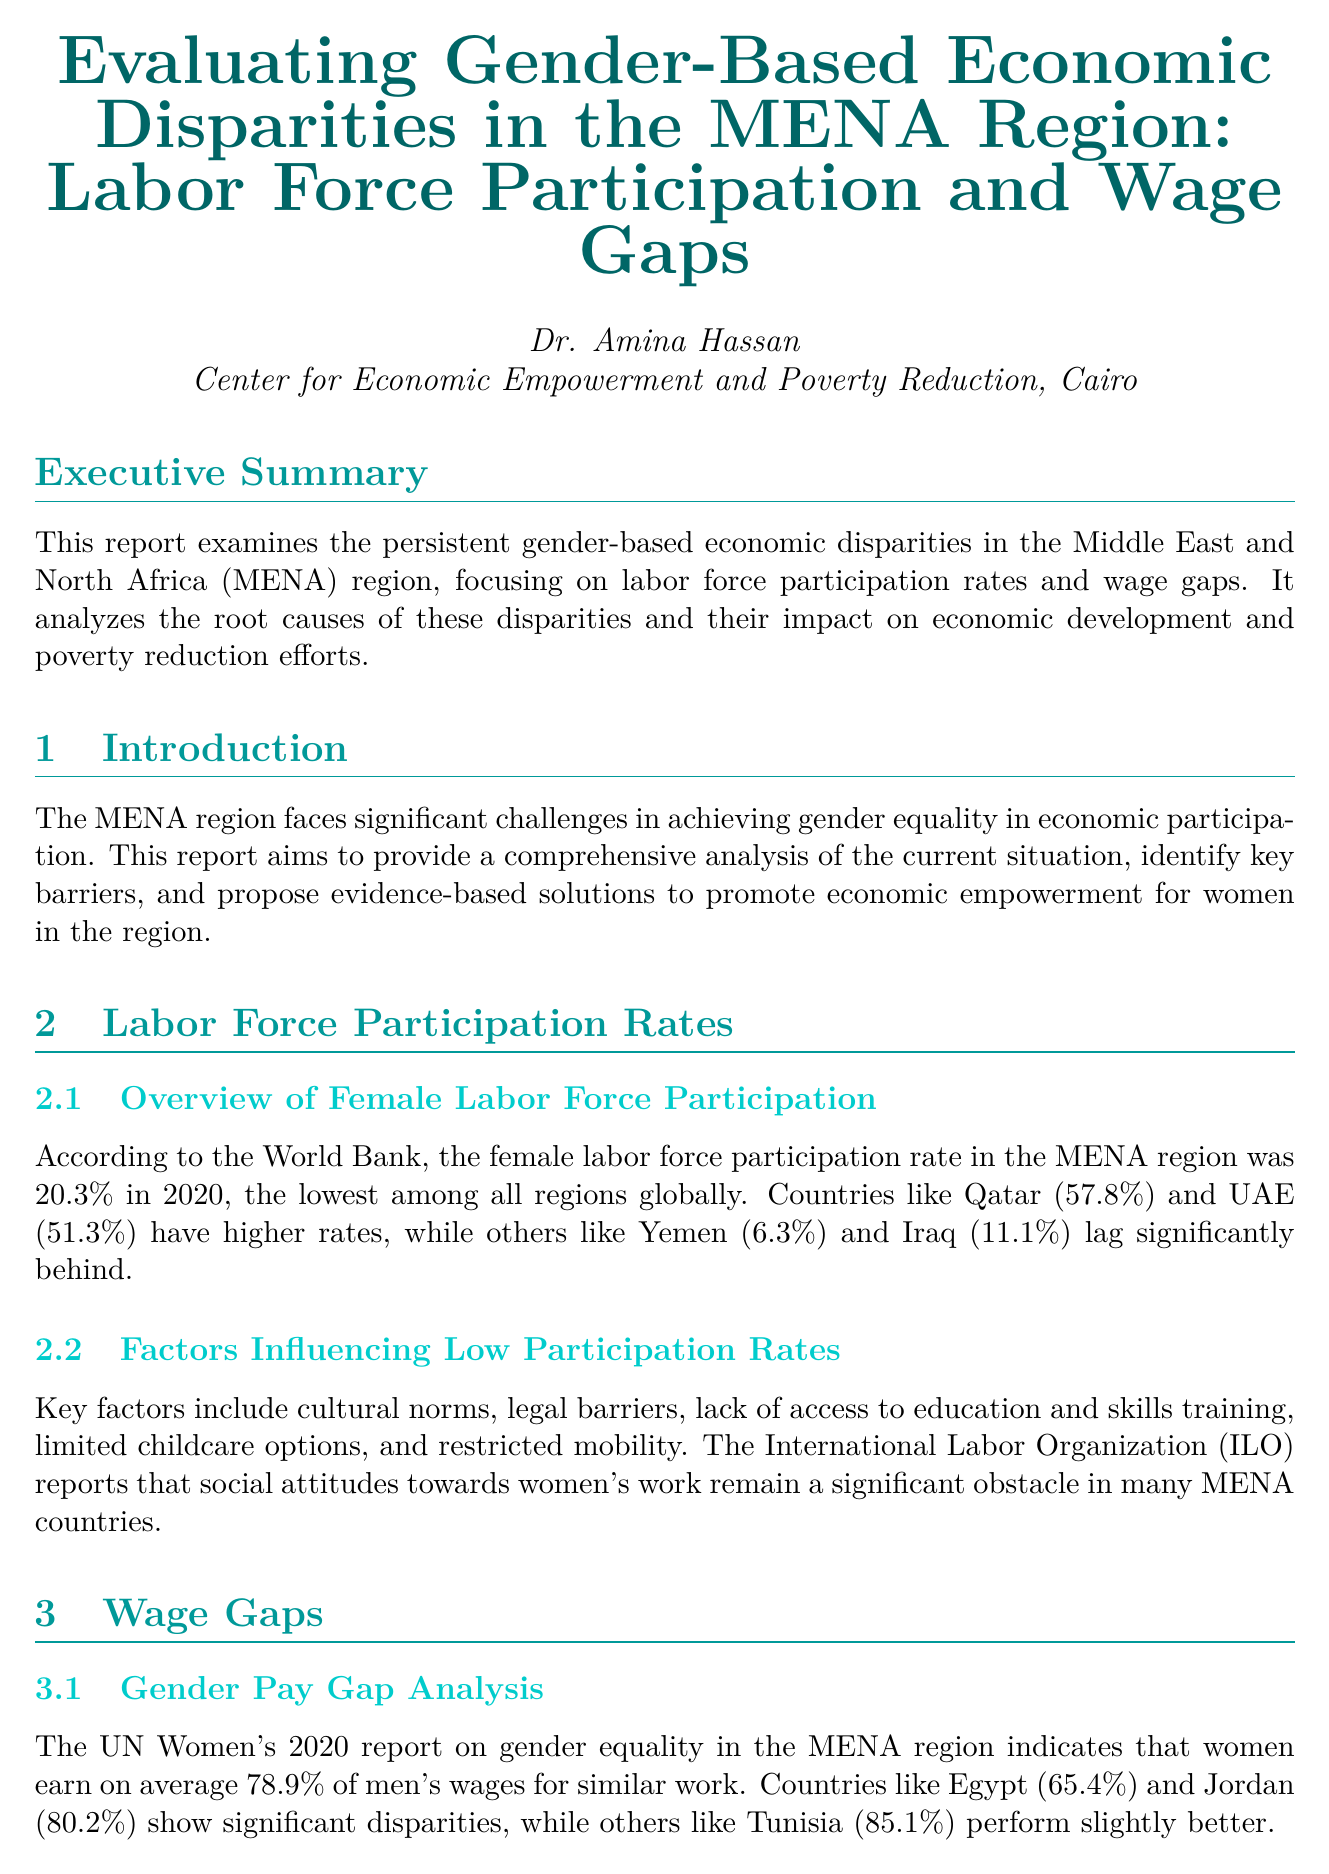What was the female labor force participation rate in the MENA region in 2020? The report states that the female labor force participation rate in the MENA region was 20.3% in 2020.
Answer: 20.3% Which country had the highest female labor force participation rate in the MENA region? According to the report, Qatar had the highest female labor force participation rate at 57.8%.
Answer: Qatar What percentage do women earn on average compared to men for similar work in the MENA region? The UN Women's 2020 report indicates that women earn on average 78.9% of men's wages for similar work.
Answer: 78.9% Which policy is recommended to support work-life balance? The report recommends implementing policies to support work-life balance, including parental leave and affordable childcare.
Answer: Parental leave and affordable childcare What economic benefit could closing the gender gap in labor force participation bring to the MENA region by 2025? The McKinsey Global Institute estimates that closing the gender gap could add up to $2.7 trillion to the MENA region's GDP by 2025.
Answer: $2.7 trillion What initiative in Morocco has promoted women's economic empowerment? The report refers to Morocco's National Initiative for Human Development (INDH) as a program that has shown promising results in promoting women's economic empowerment.
Answer: INDH How much did female labor force participation increase in the UAE between 2015 and 2020? The document states that the UAE saw a 12% increase in female labor force participation from 2015 to 2020.
Answer: 12% What are two key barriers to women's labor force participation mentioned in the report? The report identifies cultural norms and lack of access to education as key barriers to women's labor force participation.
Answer: Cultural norms and lack of access to education 